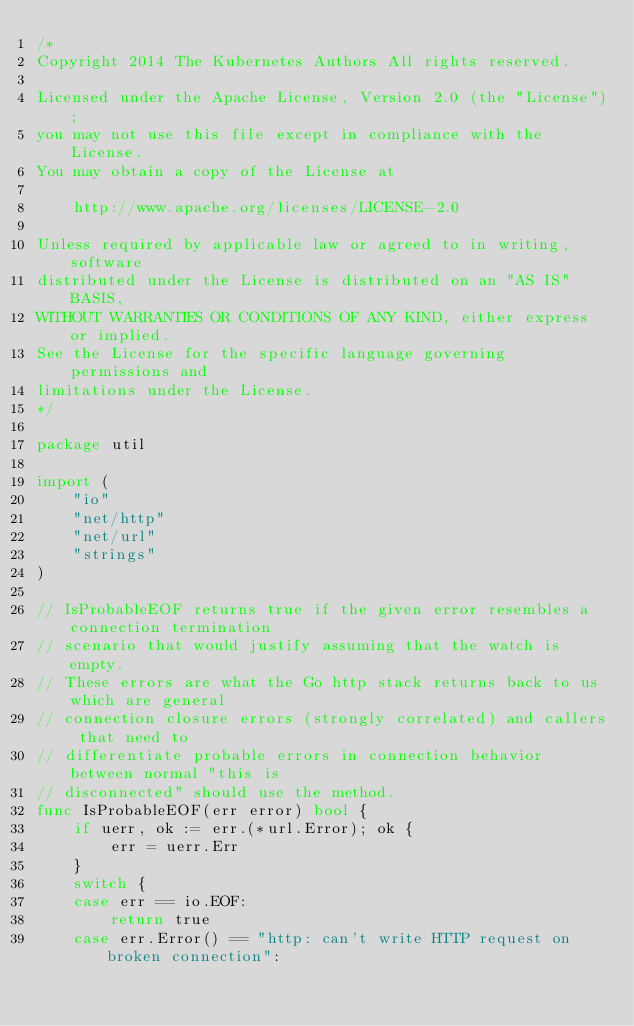<code> <loc_0><loc_0><loc_500><loc_500><_Go_>/*
Copyright 2014 The Kubernetes Authors All rights reserved.

Licensed under the Apache License, Version 2.0 (the "License");
you may not use this file except in compliance with the License.
You may obtain a copy of the License at

    http://www.apache.org/licenses/LICENSE-2.0

Unless required by applicable law or agreed to in writing, software
distributed under the License is distributed on an "AS IS" BASIS,
WITHOUT WARRANTIES OR CONDITIONS OF ANY KIND, either express or implied.
See the License for the specific language governing permissions and
limitations under the License.
*/

package util

import (
	"io"
	"net/http"
	"net/url"
	"strings"
)

// IsProbableEOF returns true if the given error resembles a connection termination
// scenario that would justify assuming that the watch is empty.
// These errors are what the Go http stack returns back to us which are general
// connection closure errors (strongly correlated) and callers that need to
// differentiate probable errors in connection behavior between normal "this is
// disconnected" should use the method.
func IsProbableEOF(err error) bool {
	if uerr, ok := err.(*url.Error); ok {
		err = uerr.Err
	}
	switch {
	case err == io.EOF:
		return true
	case err.Error() == "http: can't write HTTP request on broken connection":</code> 